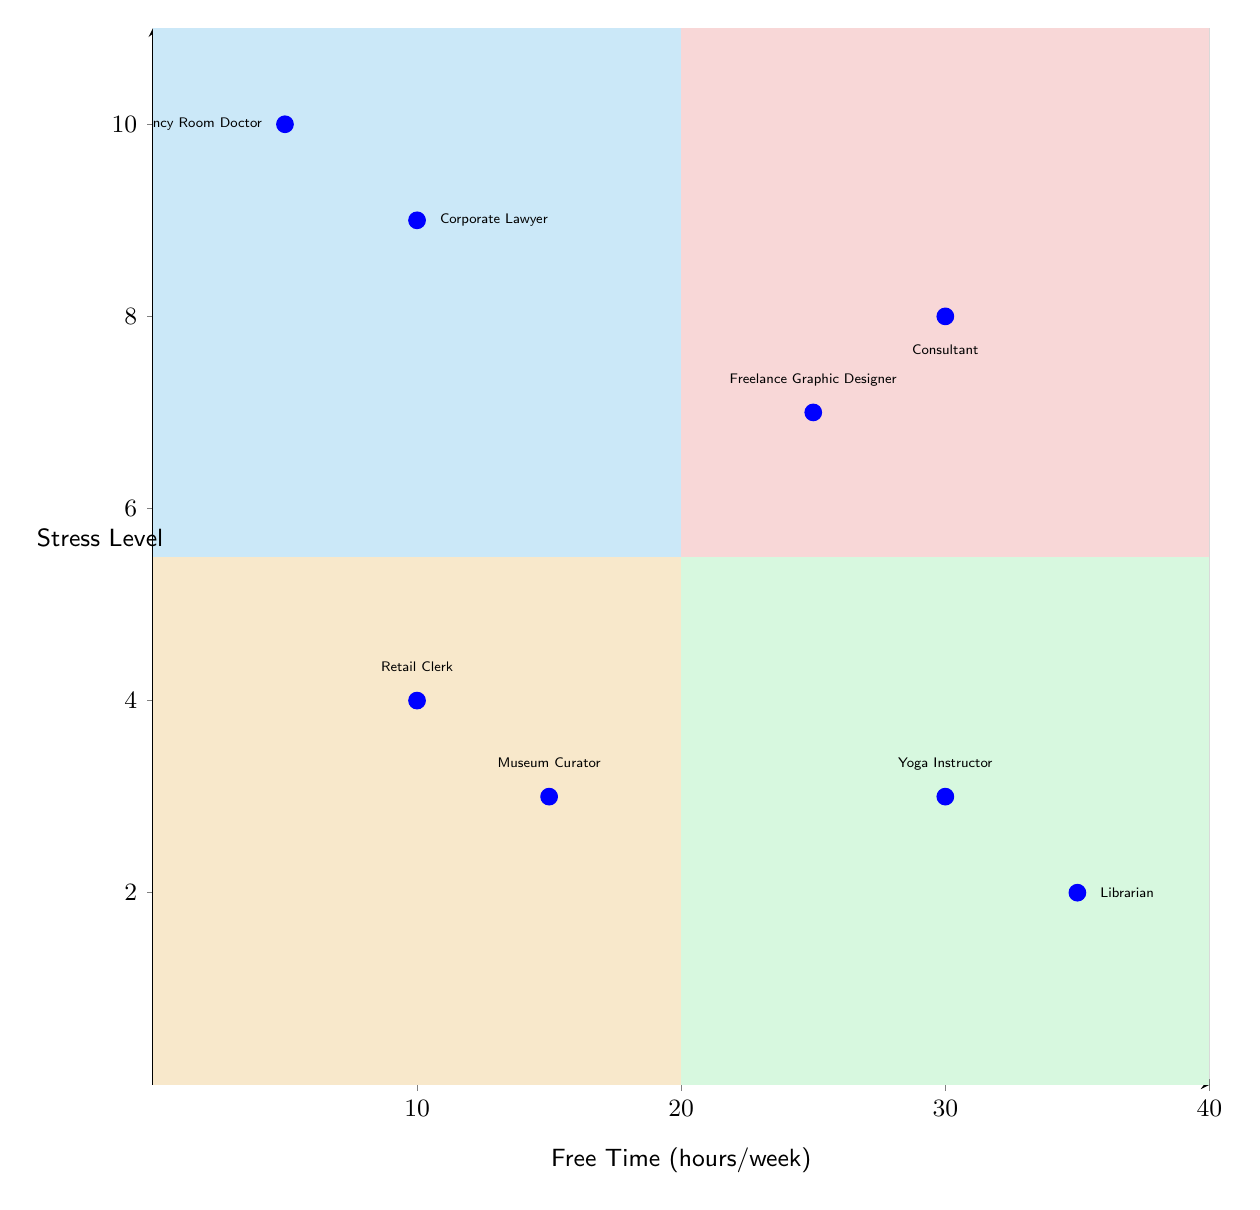What job role has the highest stress level? To find the highest stress level, look at the job roles listed in the quadrants and identify the one with the highest reported stress level. The Emergency Room Doctor has a stress level of 10, which is the highest among all job roles.
Answer: Emergency Room Doctor How many job roles are in the "Low Stress, High Free Time" quadrant? Count the job roles listed within the "Low Stress, High Free Time" quadrant. There are two job roles: Librarian and Yoga Instructor.
Answer: 2 What is the average free time of a Consultant? Refer to the information provided for the Consultant's job role in the diagram. The Consultant has an average free time of 30 hours per week.
Answer: 30 Which job role has the least free time? Examine the free time values listed for each job role. The Emergency Room Doctor has the least free time at 5 hours per week.
Answer: Emergency Room Doctor What is the stress level of the Freelance Graphic Designer? Look at the quadrant containing the Freelance Graphic Designer and find the corresponding stress level. The stress level for the Freelance Graphic Designer is 7.
Answer: 7 In which quadrant do you find the Retail Clerk? Identify where the Retail Clerk is positioned in the diagram. The Retail Clerk is located in the "Low Stress, Low Free Time" quadrant.
Answer: Low Stress, Low Free Time Which two job roles have low stress levels? Review all the job roles and their associated stress levels. The Librarian (stress level 2) and Museum Curator (stress level 3) both have low stress levels.
Answer: Librarian, Museum Curator What is the average free time of the Corporate Lawyer? Look up the Corporate Lawyer’s average free time in the diagram, which is clearly stated as 10 hours per week.
Answer: 10 How many total job roles are represented in the diagram? Count all the job roles listed across all four quadrants. There are eight job roles in total.
Answer: 8 